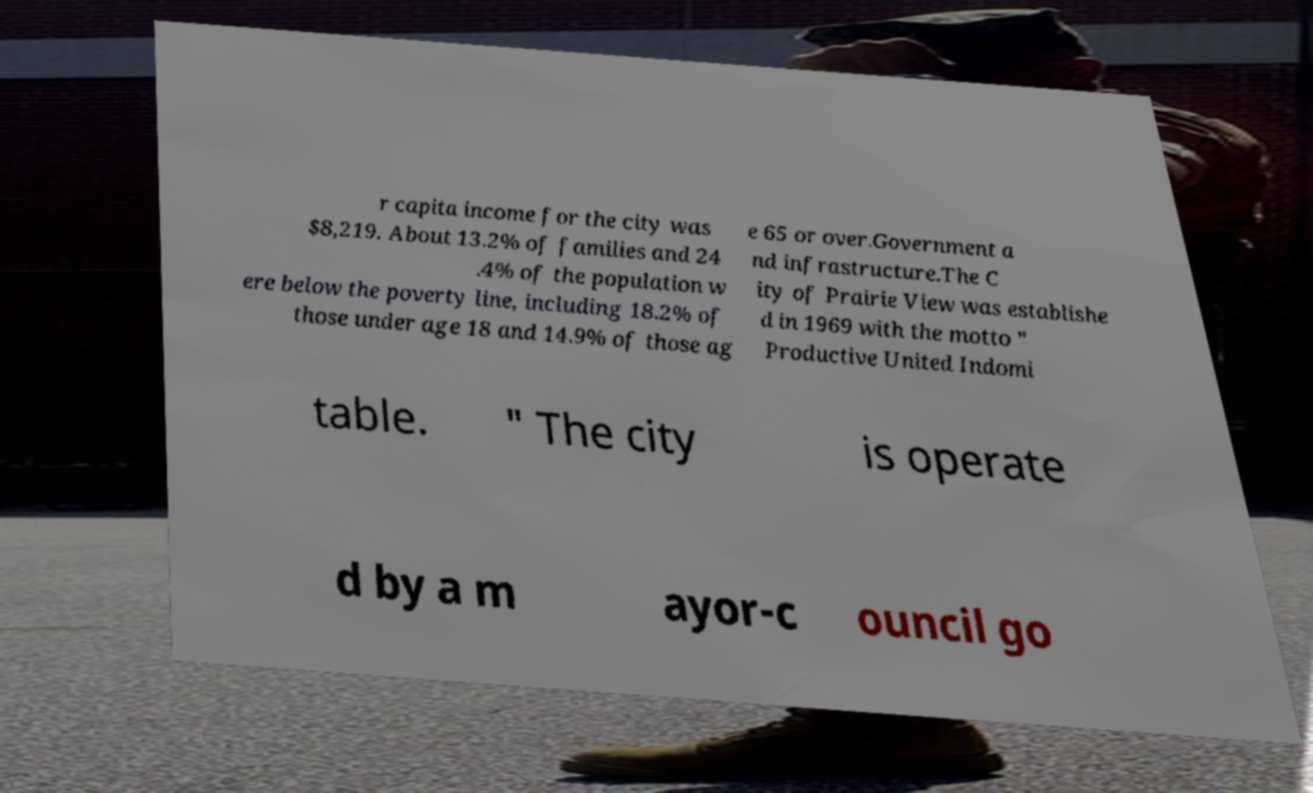Can you read and provide the text displayed in the image?This photo seems to have some interesting text. Can you extract and type it out for me? r capita income for the city was $8,219. About 13.2% of families and 24 .4% of the population w ere below the poverty line, including 18.2% of those under age 18 and 14.9% of those ag e 65 or over.Government a nd infrastructure.The C ity of Prairie View was establishe d in 1969 with the motto " Productive United Indomi table. " The city is operate d by a m ayor-c ouncil go 